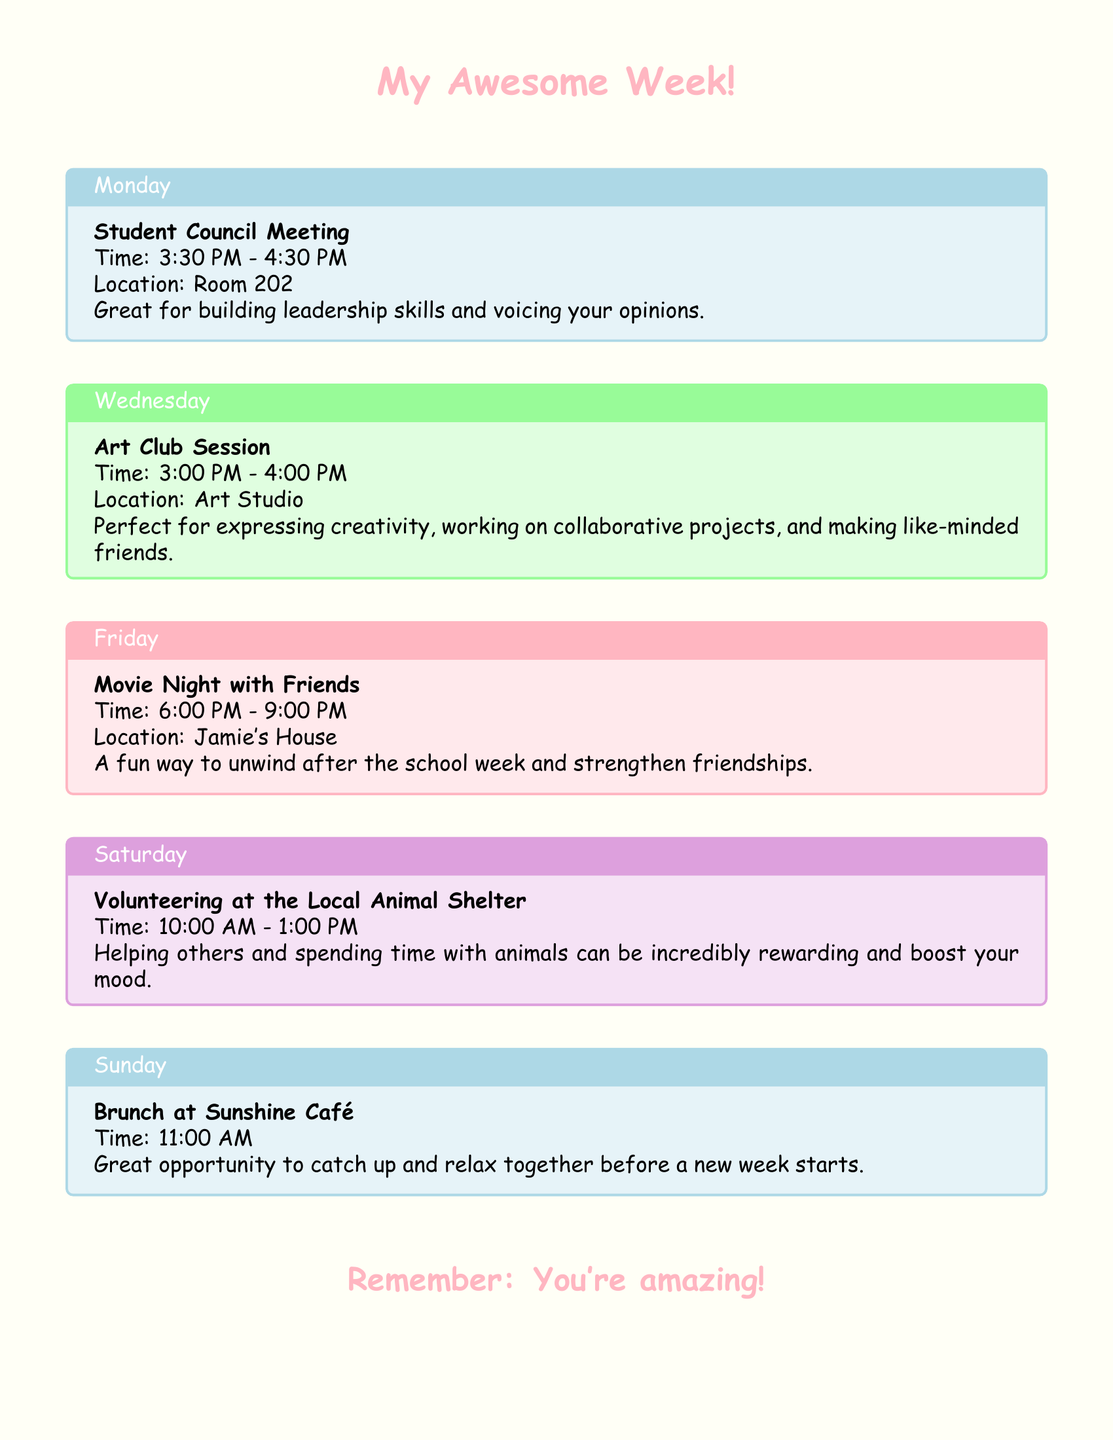What event is scheduled for Monday? The document lists the Student Council Meeting as the event for Monday.
Answer: Student Council Meeting What time does the Art Club session start? The Art Club Session is scheduled to start at 3:00 PM on Wednesday.
Answer: 3:00 PM Where is the Movie Night with Friends taking place? According to the document, the Movie Night with Friends is at Jamie's House.
Answer: Jamie's House What day is the volunteering opportunity at the Local Animal Shelter? The document states that volunteering at the Local Animal Shelter occurs on Saturday.
Answer: Saturday How long is the Student Council Meeting? The Student Council Meeting is scheduled for one hour, from 3:30 PM to 4:30 PM.
Answer: One hour What type of skills can you build at the Student Council Meeting? The document mentions that attending the meeting helps build leadership skills.
Answer: Leadership skills What is an activity you can do at the Art Club Session? The Art Club Session is described as perfect for working on collaborative projects.
Answer: Collaborative projects What is the purpose of the Sunday brunch? The brunch at Sunshine Café is a great opportunity to catch up and relax.
Answer: Catch up and relax What is the mood-boosting activity mentioned in the volunteering section? The document states that spending time with animals can boost your mood.
Answer: Spending time with animals 